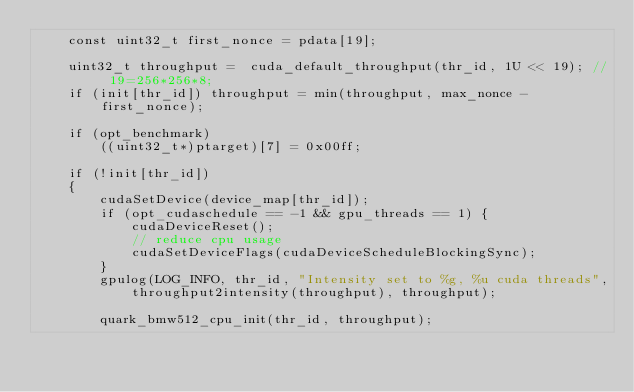Convert code to text. <code><loc_0><loc_0><loc_500><loc_500><_Cuda_>	const uint32_t first_nonce = pdata[19];

	uint32_t throughput =  cuda_default_throughput(thr_id, 1U << 19); // 19=256*256*8;
	if (init[thr_id]) throughput = min(throughput, max_nonce - first_nonce);

	if (opt_benchmark)
		((uint32_t*)ptarget)[7] = 0x00ff;

	if (!init[thr_id])
	{
		cudaSetDevice(device_map[thr_id]);
		if (opt_cudaschedule == -1 && gpu_threads == 1) {
			cudaDeviceReset();
			// reduce cpu usage
			cudaSetDeviceFlags(cudaDeviceScheduleBlockingSync);
		}
		gpulog(LOG_INFO, thr_id, "Intensity set to %g, %u cuda threads",
			throughput2intensity(throughput), throughput);

		quark_bmw512_cpu_init(thr_id, throughput);</code> 